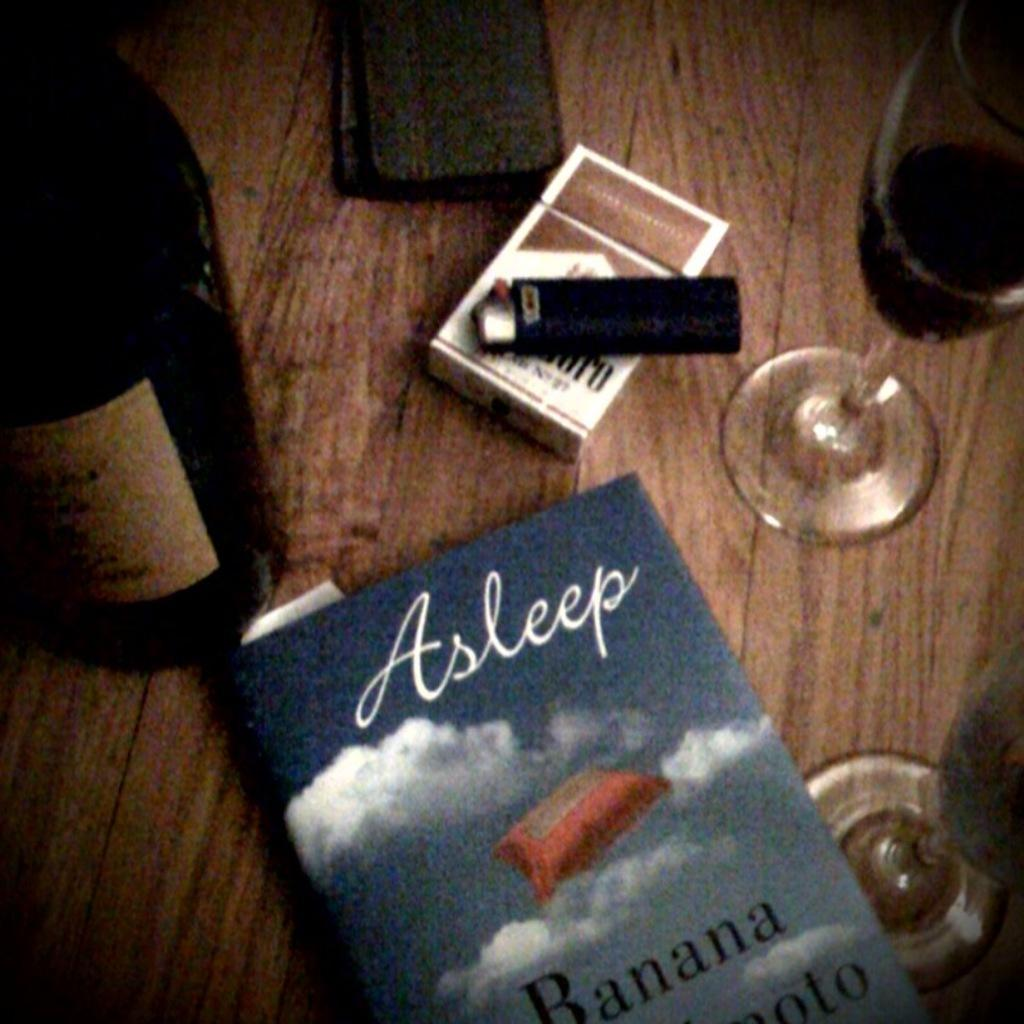<image>
Summarize the visual content of the image. A pack of Marlboros sit on a table next to a copy of Asleep. 